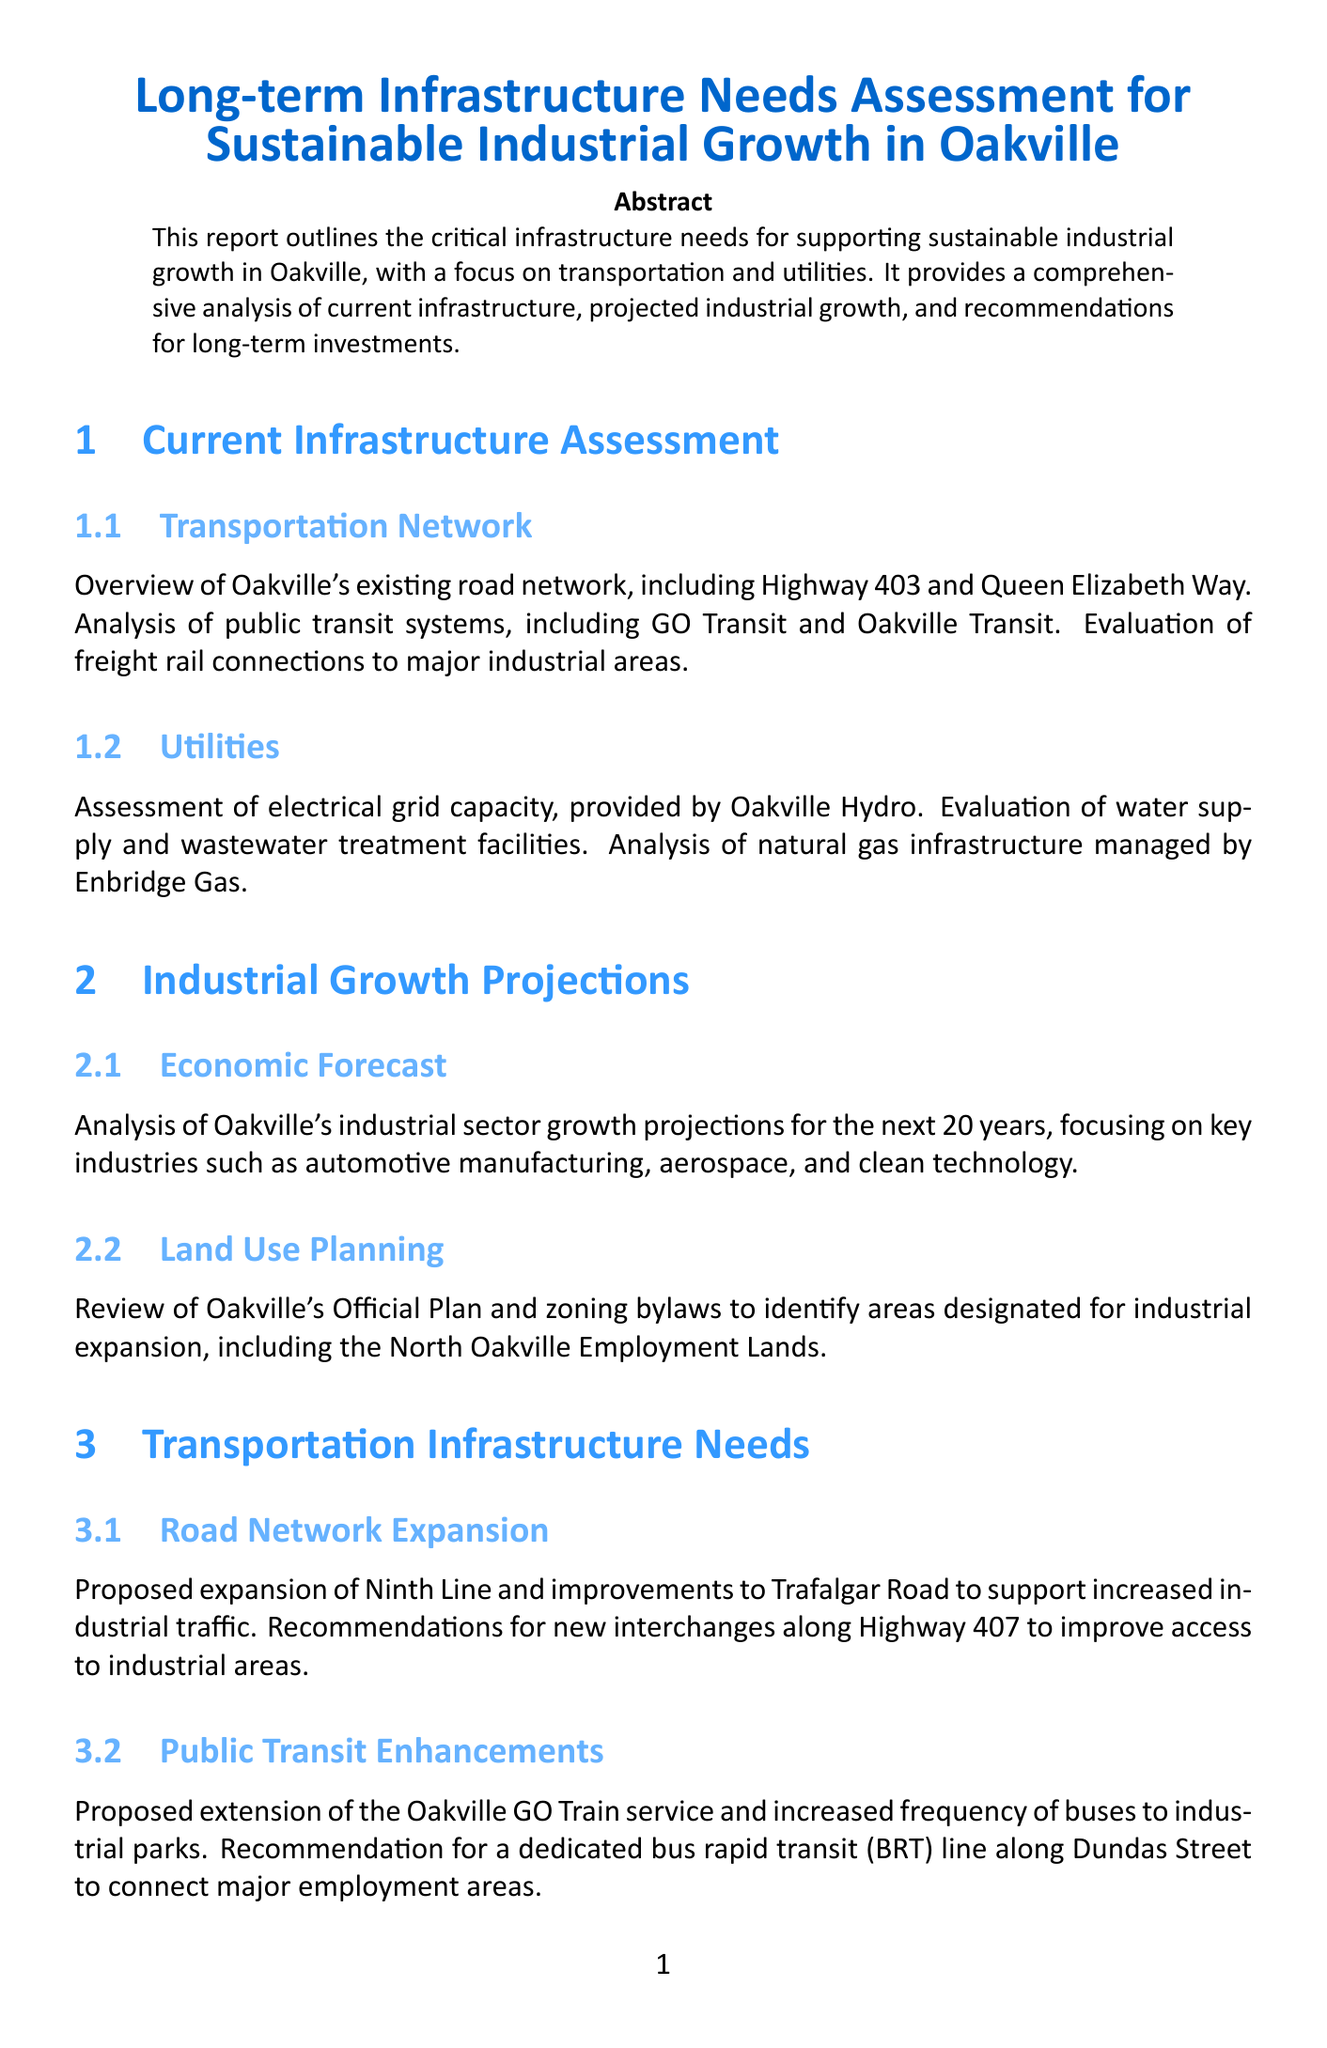What is the main focus of the report? The report outlines the infrastructure needs supporting sustainable industrial growth, particularly in transportation and utilities.
Answer: transportation and utilities What is the projected timeframe for industrial growth analysis? The analysis in the report focuses on projections for the next 20 years.
Answer: 20 years What major road is mentioned in the current transportation network? The document mentions Highway 403 as part of Oakville's existing road network.
Answer: Highway 403 What type of public transportation enhancement is proposed in the report? The report proposes an extension of the Oakville GO Train service.
Answer: extension of the Oakville GO Train service Which infrastructure project is recommended for increasing electrical capacity? A new substation is recommended for construction in the North Oakville Employment Lands.
Answer: new substation What is the primary funding strategy discussed in the report? The report explores public-private partnerships as one of the funding strategies.
Answer: Public-Private Partnerships What is one key industry identified for growth in Oakville? The automotive manufacturing industry is one of the key industries highlighted in the report.
Answer: automotive manufacturing What environmental initiative is recommended for industrial parks? Recommendations include the installation of electric vehicle charging stations in industrial parks.
Answer: electric vehicle charging stations 